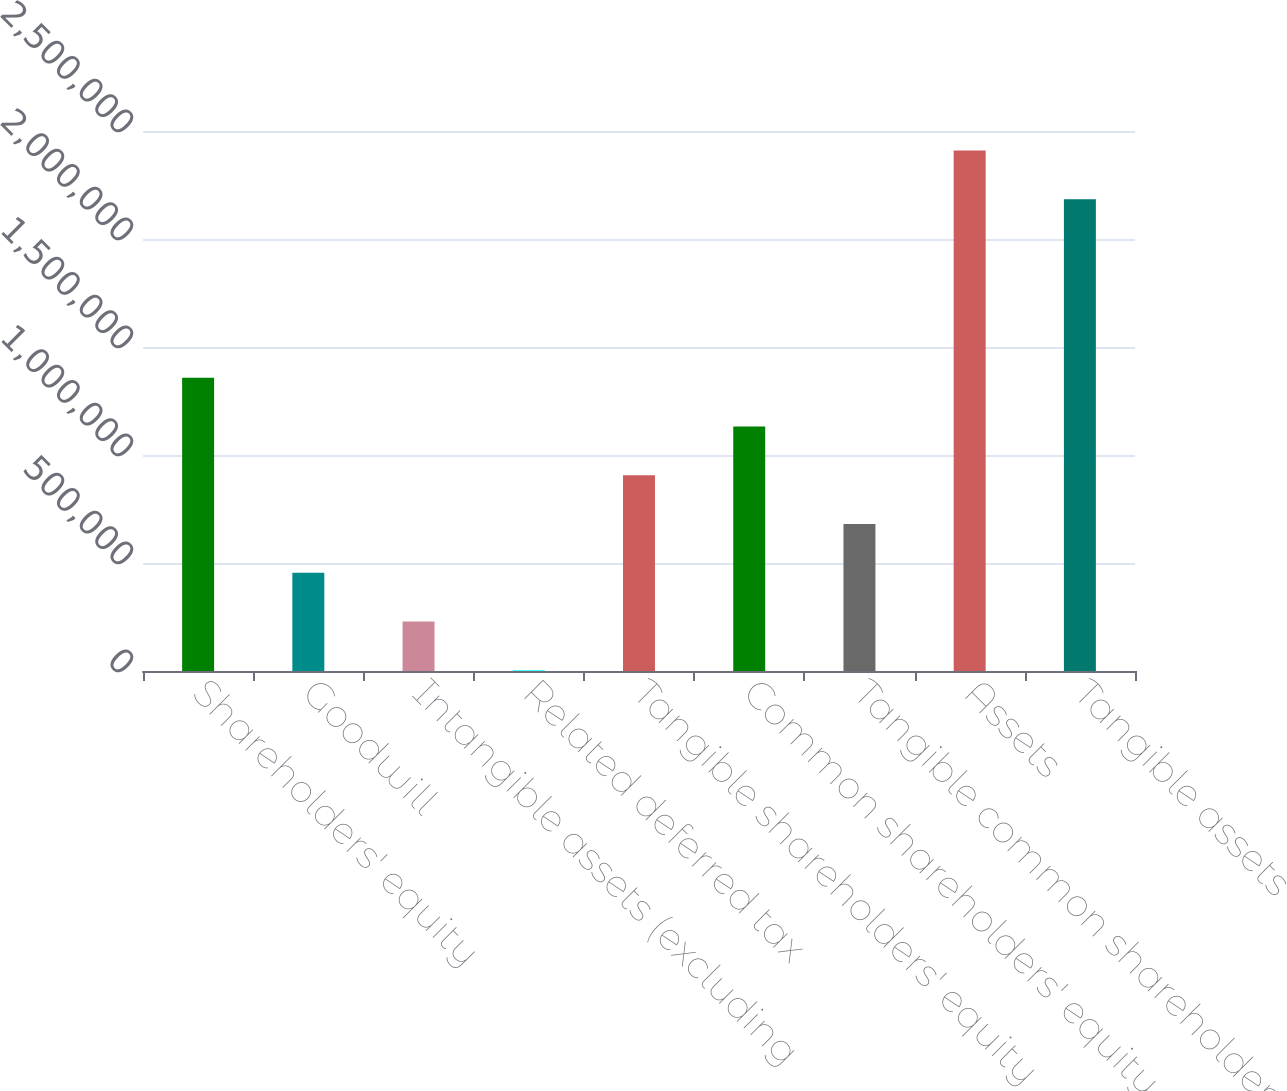Convert chart to OTSL. <chart><loc_0><loc_0><loc_500><loc_500><bar_chart><fcel>Shareholders' equity<fcel>Goodwill<fcel>Intangible assets (excluding<fcel>Related deferred tax<fcel>Tangible shareholders' equity<fcel>Common shareholders' equity<fcel>Tangible common shareholders'<fcel>Assets<fcel>Tangible assets<nl><fcel>1.35796e+06<fcel>454609<fcel>228771<fcel>2932<fcel>906287<fcel>1.13213e+06<fcel>680448<fcel>2.40976e+06<fcel>2.18392e+06<nl></chart> 